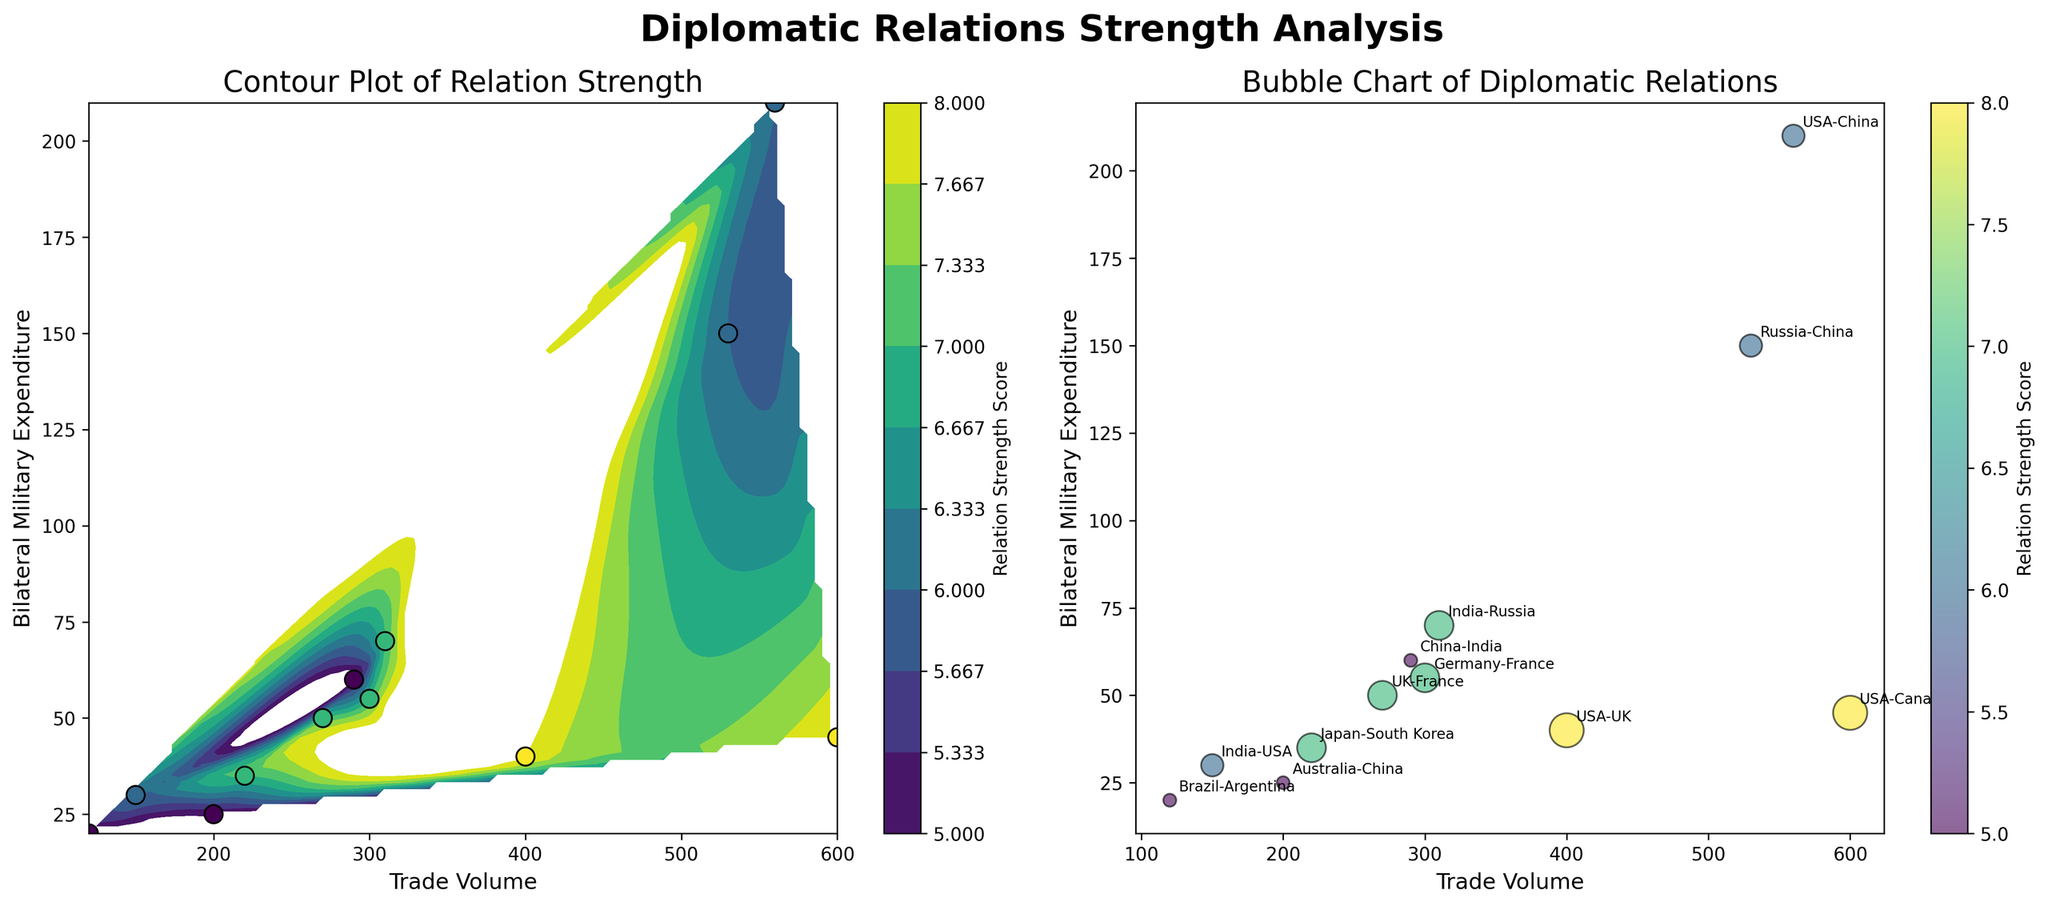What is the title of the first subplot on the left? The title of a plot is usually displayed at the top of the subplot. For the contour plot, we see the title 'Contour Plot of Relation Strength' on the top.
Answer: Contour Plot of Relation Strength How many countries are displayed in the bubble chart on the right? Each point in the bubble chart represents a pair of countries. By counting the points or pairs (annotated with labels), we see there are 12 different pairs of countries.
Answer: 12 Which pair of countries has the highest trade volume in the contour plot? The highest trade volume can be determined by locating the farthest point to the right on the x-axis in the contour plot. This point corresponds to the pair USA-Canada with a trade volume of 600.
Answer: USA-Canada What is the average Relation Strength Score of countries with a trade volume above 500 in the bubble chart? Identify the data points with trade volumes above 500 (USA-Canada and USA-China in the bubble chart). Their Relation Strength Scores are 8 and 6, respectively. The average is (8+6)/2 = 7.
Answer: 7 Which pair of countries has the lowest bilateral military expenditure in the contour plot? The pair with the lowest point on the y-axis (representing bilateral military expenditure) in the contour plot is Brazil-Argentina with an expenditure of 20.
Answer: Brazil-Argentina What are the axis labels of the bubble chart on the right? The axis labels can be found near the x and y-axes of the bubble chart. The x-axis label reads 'Trade Volume', and the y-axis label reads 'Bilateral Military Expenditure'.
Answer: Trade Volume (x-axis) and Bilateral Military Expenditure (y-axis) Which pair of countries has a Relation Strength Score of 8 in both subplots? In both the contour plot and the bubble chart, the Relation Strength Score can be identified with color coding and data points. The pairs with score 8 are USA-Canada and USA-UK. By cross-referencing, the common pair is USA-Canada.
Answer: USA-Canada How does the relation strength trend with increasing trade volume in the contour plot? By analyzing the contour lines and the changes in Relation Strength Scores as trade volume increases, we observe that higher trade volumes generally correspond to moderate to high relation strength, clustered primarily around scores of 6-8.
Answer: Generally increases 